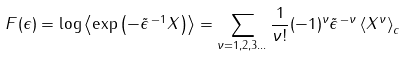<formula> <loc_0><loc_0><loc_500><loc_500>F ( \epsilon ) = \log \left < \exp \left ( - \tilde { \epsilon } ^ { \, - 1 } X \right ) \right > = \sum _ { \nu = 1 , 2 , 3 \dots } \frac { 1 } { \nu ! } ( - 1 ) ^ { \nu } \tilde { \epsilon } ^ { \, - \nu } \left < X ^ { \nu } \right > _ { c }</formula> 